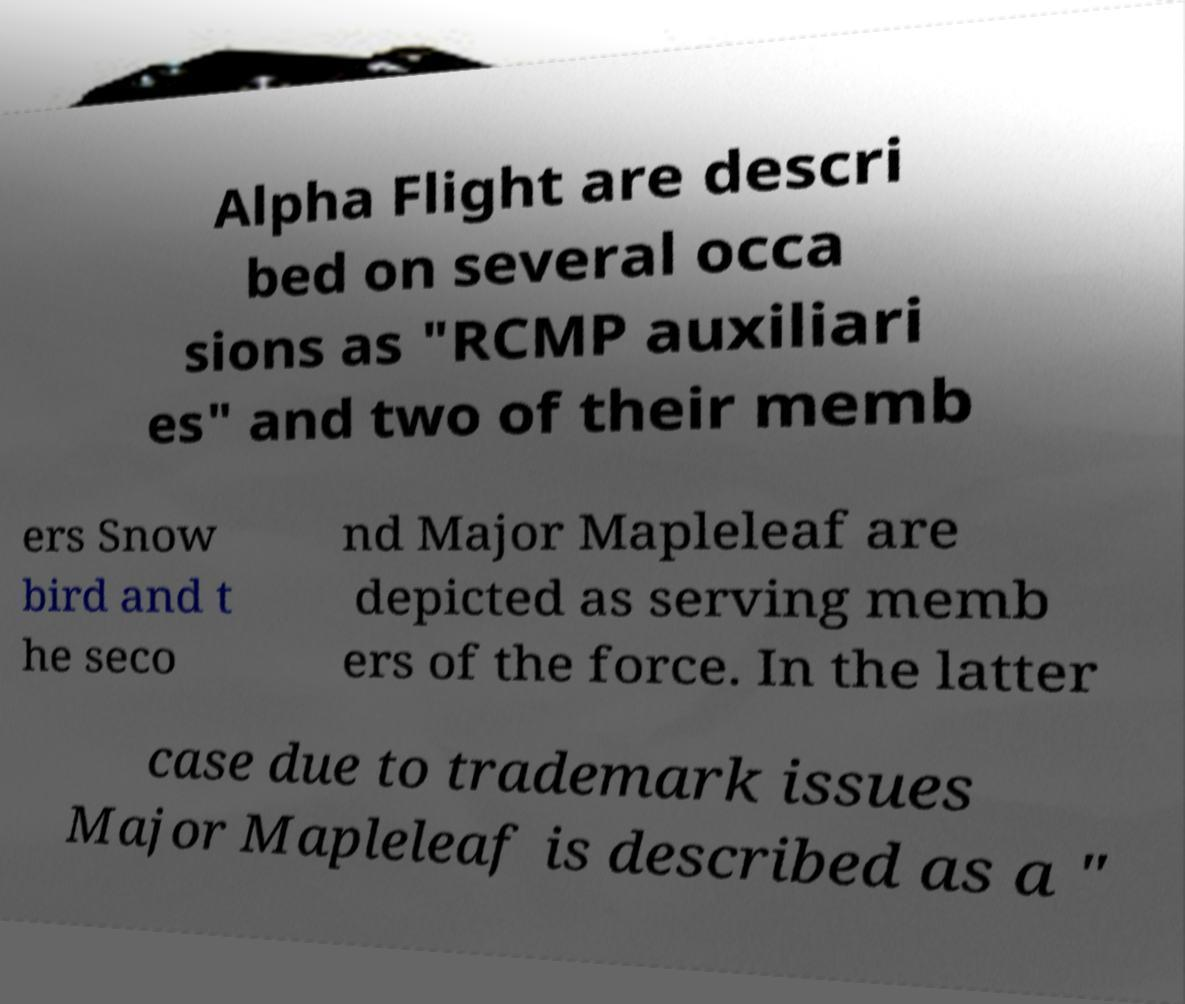There's text embedded in this image that I need extracted. Can you transcribe it verbatim? Alpha Flight are descri bed on several occa sions as "RCMP auxiliari es" and two of their memb ers Snow bird and t he seco nd Major Mapleleaf are depicted as serving memb ers of the force. In the latter case due to trademark issues Major Mapleleaf is described as a " 